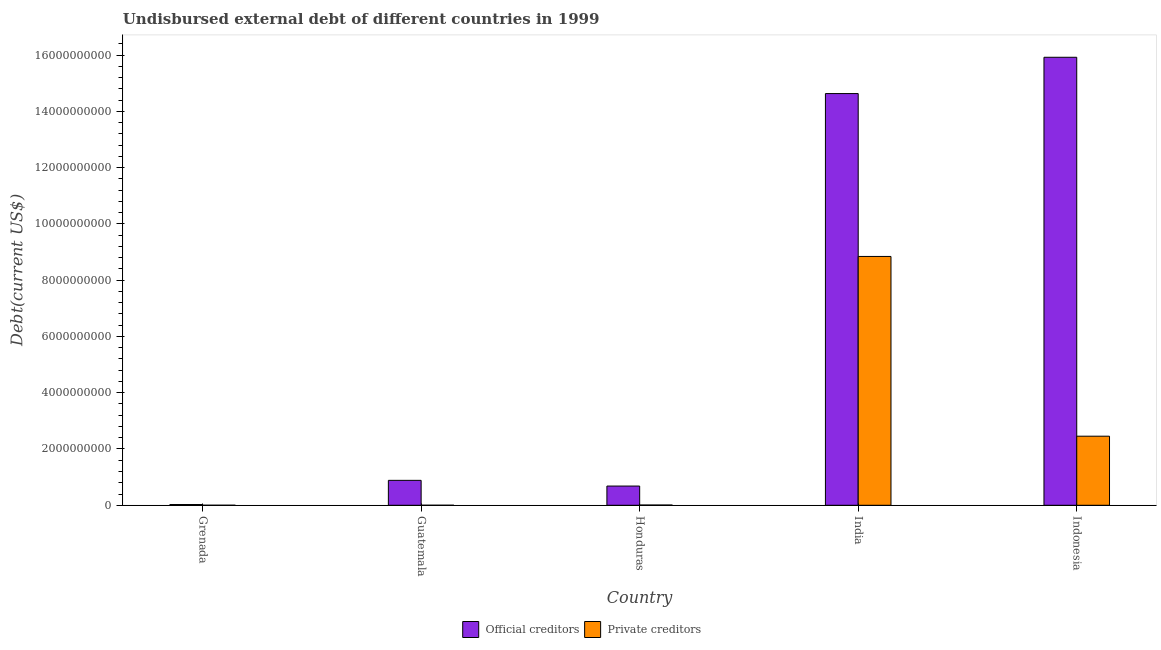How many groups of bars are there?
Ensure brevity in your answer.  5. Are the number of bars per tick equal to the number of legend labels?
Provide a succinct answer. Yes. What is the label of the 3rd group of bars from the left?
Your answer should be compact. Honduras. What is the undisbursed external debt of official creditors in Indonesia?
Ensure brevity in your answer.  1.59e+1. Across all countries, what is the maximum undisbursed external debt of official creditors?
Provide a succinct answer. 1.59e+1. Across all countries, what is the minimum undisbursed external debt of official creditors?
Make the answer very short. 2.69e+07. In which country was the undisbursed external debt of official creditors maximum?
Make the answer very short. Indonesia. In which country was the undisbursed external debt of official creditors minimum?
Provide a succinct answer. Grenada. What is the total undisbursed external debt of private creditors in the graph?
Your answer should be very brief. 1.13e+1. What is the difference between the undisbursed external debt of official creditors in India and that in Indonesia?
Offer a very short reply. -1.29e+09. What is the difference between the undisbursed external debt of official creditors in Grenada and the undisbursed external debt of private creditors in Honduras?
Keep it short and to the point. 1.81e+07. What is the average undisbursed external debt of private creditors per country?
Your answer should be compact. 2.26e+09. What is the difference between the undisbursed external debt of official creditors and undisbursed external debt of private creditors in Honduras?
Your answer should be compact. 6.74e+08. What is the ratio of the undisbursed external debt of official creditors in Honduras to that in India?
Give a very brief answer. 0.05. Is the undisbursed external debt of private creditors in Grenada less than that in Guatemala?
Give a very brief answer. Yes. What is the difference between the highest and the second highest undisbursed external debt of official creditors?
Your response must be concise. 1.29e+09. What is the difference between the highest and the lowest undisbursed external debt of official creditors?
Provide a short and direct response. 1.59e+1. In how many countries, is the undisbursed external debt of official creditors greater than the average undisbursed external debt of official creditors taken over all countries?
Keep it short and to the point. 2. Is the sum of the undisbursed external debt of official creditors in Guatemala and Honduras greater than the maximum undisbursed external debt of private creditors across all countries?
Give a very brief answer. No. What does the 2nd bar from the left in Indonesia represents?
Your answer should be compact. Private creditors. What does the 2nd bar from the right in Honduras represents?
Provide a succinct answer. Official creditors. What is the difference between two consecutive major ticks on the Y-axis?
Ensure brevity in your answer.  2.00e+09. Are the values on the major ticks of Y-axis written in scientific E-notation?
Keep it short and to the point. No. Does the graph contain grids?
Provide a succinct answer. No. How many legend labels are there?
Make the answer very short. 2. What is the title of the graph?
Ensure brevity in your answer.  Undisbursed external debt of different countries in 1999. What is the label or title of the X-axis?
Keep it short and to the point. Country. What is the label or title of the Y-axis?
Offer a very short reply. Debt(current US$). What is the Debt(current US$) in Official creditors in Grenada?
Provide a succinct answer. 2.69e+07. What is the Debt(current US$) of Private creditors in Grenada?
Make the answer very short. 1.17e+06. What is the Debt(current US$) in Official creditors in Guatemala?
Your answer should be compact. 8.86e+08. What is the Debt(current US$) of Private creditors in Guatemala?
Offer a terse response. 1.17e+06. What is the Debt(current US$) in Official creditors in Honduras?
Provide a short and direct response. 6.83e+08. What is the Debt(current US$) in Private creditors in Honduras?
Keep it short and to the point. 8.78e+06. What is the Debt(current US$) of Official creditors in India?
Offer a terse response. 1.46e+1. What is the Debt(current US$) in Private creditors in India?
Your answer should be compact. 8.84e+09. What is the Debt(current US$) in Official creditors in Indonesia?
Your answer should be compact. 1.59e+1. What is the Debt(current US$) of Private creditors in Indonesia?
Provide a succinct answer. 2.45e+09. Across all countries, what is the maximum Debt(current US$) of Official creditors?
Your answer should be very brief. 1.59e+1. Across all countries, what is the maximum Debt(current US$) in Private creditors?
Make the answer very short. 8.84e+09. Across all countries, what is the minimum Debt(current US$) of Official creditors?
Give a very brief answer. 2.69e+07. Across all countries, what is the minimum Debt(current US$) in Private creditors?
Your response must be concise. 1.17e+06. What is the total Debt(current US$) of Official creditors in the graph?
Give a very brief answer. 3.21e+1. What is the total Debt(current US$) of Private creditors in the graph?
Offer a very short reply. 1.13e+1. What is the difference between the Debt(current US$) of Official creditors in Grenada and that in Guatemala?
Your answer should be very brief. -8.59e+08. What is the difference between the Debt(current US$) of Private creditors in Grenada and that in Guatemala?
Your answer should be very brief. -1000. What is the difference between the Debt(current US$) in Official creditors in Grenada and that in Honduras?
Your answer should be compact. -6.56e+08. What is the difference between the Debt(current US$) of Private creditors in Grenada and that in Honduras?
Give a very brief answer. -7.62e+06. What is the difference between the Debt(current US$) in Official creditors in Grenada and that in India?
Your answer should be compact. -1.46e+1. What is the difference between the Debt(current US$) of Private creditors in Grenada and that in India?
Ensure brevity in your answer.  -8.84e+09. What is the difference between the Debt(current US$) in Official creditors in Grenada and that in Indonesia?
Provide a succinct answer. -1.59e+1. What is the difference between the Debt(current US$) in Private creditors in Grenada and that in Indonesia?
Your answer should be very brief. -2.45e+09. What is the difference between the Debt(current US$) in Official creditors in Guatemala and that in Honduras?
Offer a terse response. 2.03e+08. What is the difference between the Debt(current US$) in Private creditors in Guatemala and that in Honduras?
Provide a short and direct response. -7.62e+06. What is the difference between the Debt(current US$) in Official creditors in Guatemala and that in India?
Your answer should be very brief. -1.37e+1. What is the difference between the Debt(current US$) in Private creditors in Guatemala and that in India?
Give a very brief answer. -8.84e+09. What is the difference between the Debt(current US$) in Official creditors in Guatemala and that in Indonesia?
Offer a terse response. -1.50e+1. What is the difference between the Debt(current US$) of Private creditors in Guatemala and that in Indonesia?
Offer a very short reply. -2.45e+09. What is the difference between the Debt(current US$) of Official creditors in Honduras and that in India?
Provide a short and direct response. -1.39e+1. What is the difference between the Debt(current US$) of Private creditors in Honduras and that in India?
Your response must be concise. -8.83e+09. What is the difference between the Debt(current US$) of Official creditors in Honduras and that in Indonesia?
Keep it short and to the point. -1.52e+1. What is the difference between the Debt(current US$) of Private creditors in Honduras and that in Indonesia?
Provide a succinct answer. -2.45e+09. What is the difference between the Debt(current US$) of Official creditors in India and that in Indonesia?
Your answer should be compact. -1.29e+09. What is the difference between the Debt(current US$) in Private creditors in India and that in Indonesia?
Provide a short and direct response. 6.39e+09. What is the difference between the Debt(current US$) in Official creditors in Grenada and the Debt(current US$) in Private creditors in Guatemala?
Give a very brief answer. 2.57e+07. What is the difference between the Debt(current US$) of Official creditors in Grenada and the Debt(current US$) of Private creditors in Honduras?
Your answer should be compact. 1.81e+07. What is the difference between the Debt(current US$) of Official creditors in Grenada and the Debt(current US$) of Private creditors in India?
Your response must be concise. -8.82e+09. What is the difference between the Debt(current US$) in Official creditors in Grenada and the Debt(current US$) in Private creditors in Indonesia?
Keep it short and to the point. -2.43e+09. What is the difference between the Debt(current US$) in Official creditors in Guatemala and the Debt(current US$) in Private creditors in Honduras?
Your answer should be compact. 8.77e+08. What is the difference between the Debt(current US$) of Official creditors in Guatemala and the Debt(current US$) of Private creditors in India?
Your response must be concise. -7.96e+09. What is the difference between the Debt(current US$) of Official creditors in Guatemala and the Debt(current US$) of Private creditors in Indonesia?
Keep it short and to the point. -1.57e+09. What is the difference between the Debt(current US$) of Official creditors in Honduras and the Debt(current US$) of Private creditors in India?
Ensure brevity in your answer.  -8.16e+09. What is the difference between the Debt(current US$) of Official creditors in Honduras and the Debt(current US$) of Private creditors in Indonesia?
Ensure brevity in your answer.  -1.77e+09. What is the difference between the Debt(current US$) of Official creditors in India and the Debt(current US$) of Private creditors in Indonesia?
Provide a succinct answer. 1.22e+1. What is the average Debt(current US$) of Official creditors per country?
Keep it short and to the point. 6.43e+09. What is the average Debt(current US$) of Private creditors per country?
Offer a very short reply. 2.26e+09. What is the difference between the Debt(current US$) in Official creditors and Debt(current US$) in Private creditors in Grenada?
Your response must be concise. 2.57e+07. What is the difference between the Debt(current US$) in Official creditors and Debt(current US$) in Private creditors in Guatemala?
Your answer should be very brief. 8.85e+08. What is the difference between the Debt(current US$) of Official creditors and Debt(current US$) of Private creditors in Honduras?
Offer a terse response. 6.74e+08. What is the difference between the Debt(current US$) of Official creditors and Debt(current US$) of Private creditors in India?
Give a very brief answer. 5.79e+09. What is the difference between the Debt(current US$) of Official creditors and Debt(current US$) of Private creditors in Indonesia?
Your answer should be very brief. 1.35e+1. What is the ratio of the Debt(current US$) in Official creditors in Grenada to that in Guatemala?
Your answer should be very brief. 0.03. What is the ratio of the Debt(current US$) in Private creditors in Grenada to that in Guatemala?
Give a very brief answer. 1. What is the ratio of the Debt(current US$) of Official creditors in Grenada to that in Honduras?
Make the answer very short. 0.04. What is the ratio of the Debt(current US$) of Private creditors in Grenada to that in Honduras?
Provide a short and direct response. 0.13. What is the ratio of the Debt(current US$) of Official creditors in Grenada to that in India?
Ensure brevity in your answer.  0. What is the ratio of the Debt(current US$) in Official creditors in Grenada to that in Indonesia?
Make the answer very short. 0. What is the ratio of the Debt(current US$) of Official creditors in Guatemala to that in Honduras?
Your answer should be very brief. 1.3. What is the ratio of the Debt(current US$) of Private creditors in Guatemala to that in Honduras?
Make the answer very short. 0.13. What is the ratio of the Debt(current US$) in Official creditors in Guatemala to that in India?
Give a very brief answer. 0.06. What is the ratio of the Debt(current US$) of Official creditors in Guatemala to that in Indonesia?
Ensure brevity in your answer.  0.06. What is the ratio of the Debt(current US$) of Official creditors in Honduras to that in India?
Keep it short and to the point. 0.05. What is the ratio of the Debt(current US$) of Official creditors in Honduras to that in Indonesia?
Provide a short and direct response. 0.04. What is the ratio of the Debt(current US$) in Private creditors in Honduras to that in Indonesia?
Your answer should be compact. 0. What is the ratio of the Debt(current US$) of Official creditors in India to that in Indonesia?
Your response must be concise. 0.92. What is the ratio of the Debt(current US$) of Private creditors in India to that in Indonesia?
Your answer should be compact. 3.6. What is the difference between the highest and the second highest Debt(current US$) in Official creditors?
Your response must be concise. 1.29e+09. What is the difference between the highest and the second highest Debt(current US$) of Private creditors?
Ensure brevity in your answer.  6.39e+09. What is the difference between the highest and the lowest Debt(current US$) in Official creditors?
Your answer should be very brief. 1.59e+1. What is the difference between the highest and the lowest Debt(current US$) of Private creditors?
Give a very brief answer. 8.84e+09. 